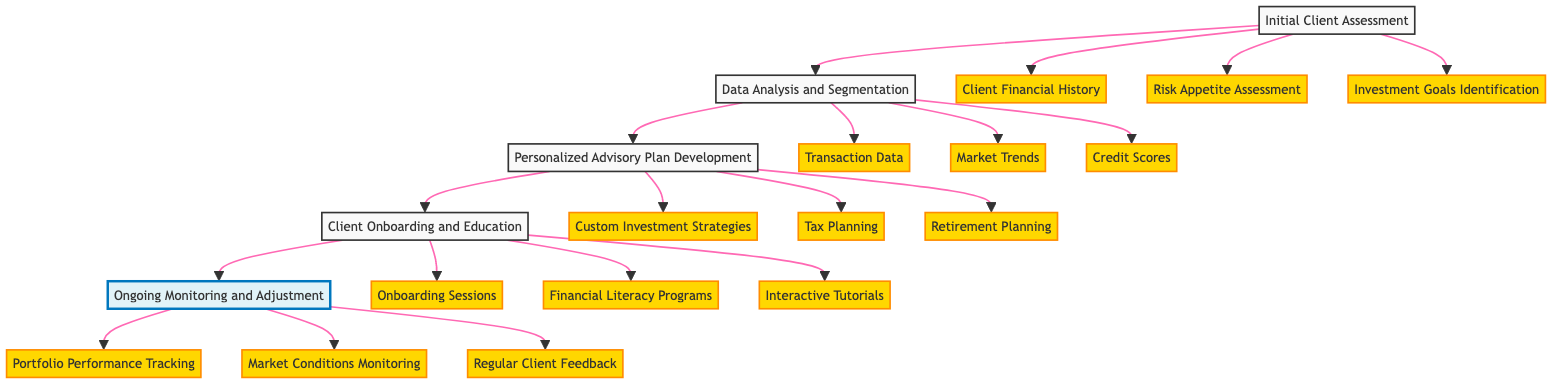What's the first step in the clinical pathway? The diagram indicates that the first step in the pathway is "Initial Client Assessment." This is the starting point and flows to the next step.
Answer: Initial Client Assessment How many tools are used in "Data Analysis and Segmentation"? In the "Data Analysis and Segmentation" section, there are three tools listed: "Predictive Analytics," "Cluster Analysis," and "Machine Learning Models," which indicates the resources employed in this phase.
Answer: Three What are the advisory components outlined in "Personalized Advisory Plan Development"? The diagram specifies three advisory components in "Personalized Advisory Plan Development": "Custom Investment Strategies," "Tax Planning," and "Retirement Planning." These components define the focus areas of the advisory plan.
Answer: Custom Investment Strategies, Tax Planning, Retirement Planning Which phase involves client education? The "Client Onboarding and Education" phase is specifically addressed in the diagram and highlights the importance of educating clients as they are onboarded.
Answer: Client Onboarding and Education How does the pathway move from "Initial Client Assessment" to "Data Analysis and Segmentation"? The pathway transitions directly from "Initial Client Assessment" to "Data Analysis and Segmentation," indicating a sequential flow where the assessment's outcomes feed into data analysis.
Answer: Direct transition What key steps are included in client onboarding? The diagram lists three key steps in client onboarding: "Onboarding Sessions," "Financial Literacy Programs," and "Interactive Tutorials," illustrating the structured approach to educate clients.
Answer: Onboarding Sessions, Financial Literacy Programs, Interactive Tutorials What components are monitored in the ongoing adjustment phase? "Portfolio Performance Tracking," "Market Conditions Monitoring," and "Regular Client Feedback" are the components monitored during the ongoing adjustment phase, ensuring active oversight of client portfolios.
Answer: Portfolio Performance Tracking, Market Conditions Monitoring, Regular Client Feedback Which tools are used during the "Client Onboarding and Education" phase? Tools used in this phase include "Video Conferencing Platforms," "E-Learning Platforms," and "Client Portals," showcasing the various methods available to facilitate client engagement and understanding.
Answer: Video Conferencing Platforms, E-Learning Platforms, Client Portals How many data sources are identified in "Data Analysis and Segmentation"? The diagram identifies three data sources: "Transaction Data," "Market Trends," and "Credit Scores," which are fundamental in informing the analysis and segmentation process.
Answer: Three 